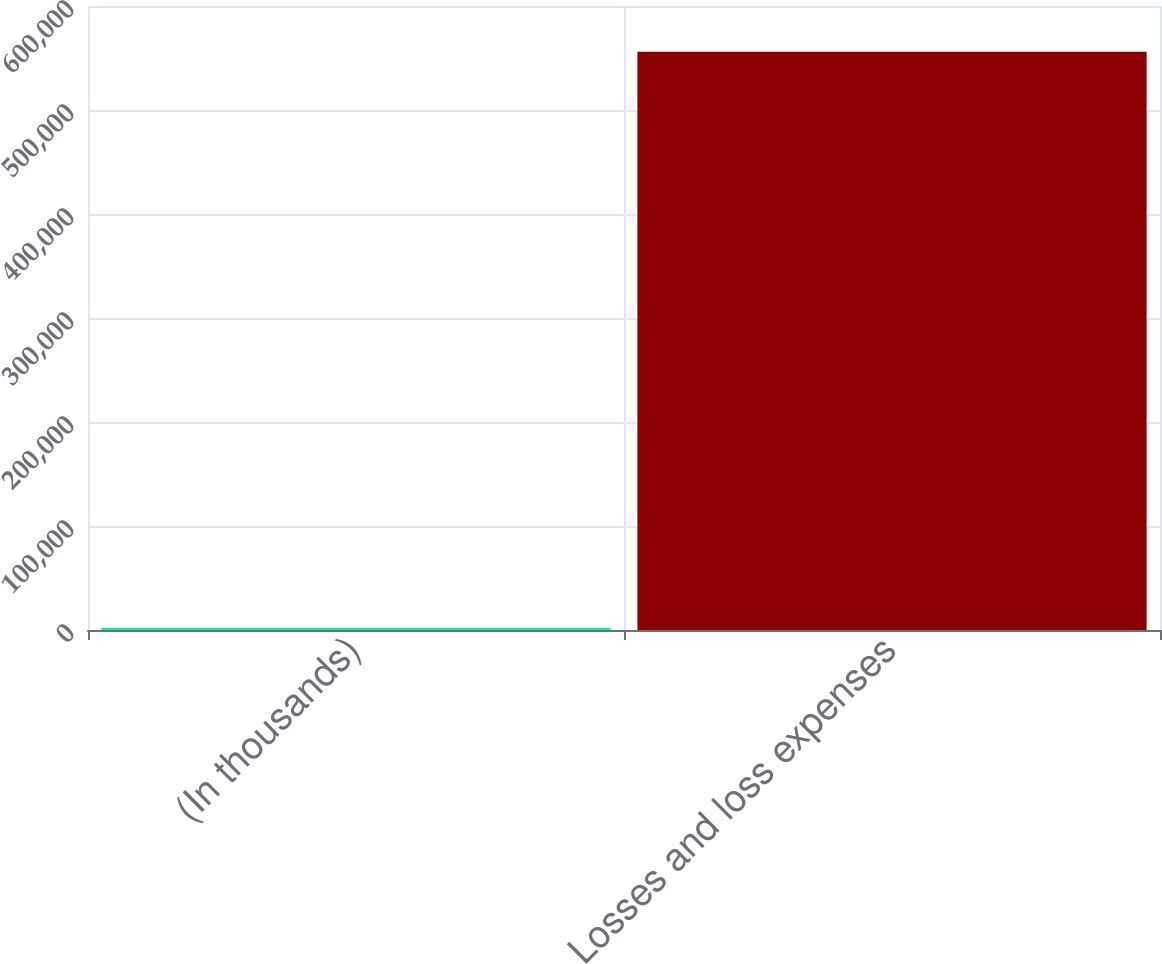Convert chart. <chart><loc_0><loc_0><loc_500><loc_500><bar_chart><fcel>(In thousands)<fcel>Losses and loss expenses<nl><fcel>2013<fcel>556108<nl></chart> 